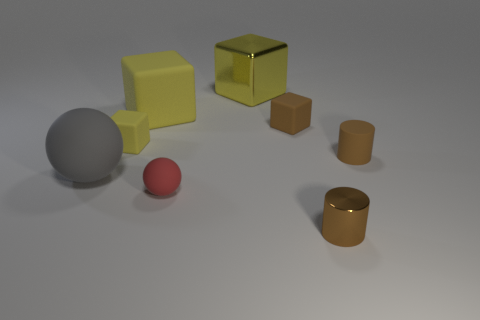There is a big rubber block; does it have the same color as the cylinder that is right of the tiny metal cylinder?
Keep it short and to the point. No. Is there anything else that is the same color as the large shiny cube?
Your answer should be compact. Yes. There is a tiny rubber object that is the same color as the big metal block; what is its shape?
Provide a succinct answer. Cube. How many things are either rubber things on the right side of the tiny red matte ball or rubber objects that are left of the brown matte cube?
Provide a succinct answer. 6. How many gray matte things have the same shape as the red rubber object?
Provide a succinct answer. 1. What is the color of the other block that is the same size as the brown matte block?
Your response must be concise. Yellow. There is a cylinder left of the small brown thing to the right of the small brown cylinder that is in front of the big ball; what is its color?
Your answer should be compact. Brown. There is a brown matte cube; is it the same size as the matte ball on the right side of the tiny yellow matte object?
Ensure brevity in your answer.  Yes. What number of objects are balls or red rubber things?
Your answer should be compact. 2. Is there a large gray ball made of the same material as the tiny yellow block?
Ensure brevity in your answer.  Yes. 